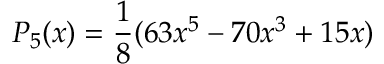Convert formula to latex. <formula><loc_0><loc_0><loc_500><loc_500>P _ { 5 } ( x ) = \frac { 1 } { 8 } ( 6 3 x ^ { 5 } - 7 0 x ^ { 3 } + 1 5 x )</formula> 